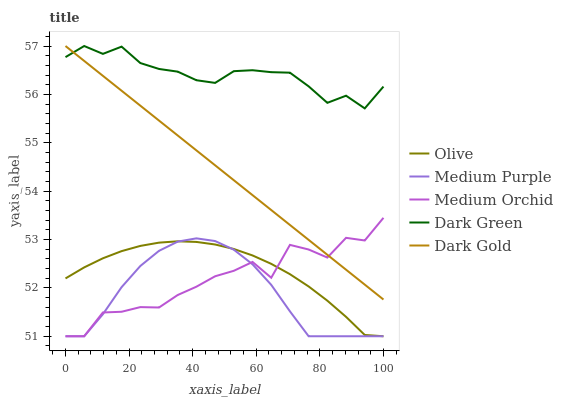Does Medium Purple have the minimum area under the curve?
Answer yes or no. Yes. Does Dark Green have the maximum area under the curve?
Answer yes or no. Yes. Does Medium Orchid have the minimum area under the curve?
Answer yes or no. No. Does Medium Orchid have the maximum area under the curve?
Answer yes or no. No. Is Dark Gold the smoothest?
Answer yes or no. Yes. Is Medium Orchid the roughest?
Answer yes or no. Yes. Is Medium Purple the smoothest?
Answer yes or no. No. Is Medium Purple the roughest?
Answer yes or no. No. Does Dark Gold have the lowest value?
Answer yes or no. No. Does Dark Green have the highest value?
Answer yes or no. Yes. Does Medium Purple have the highest value?
Answer yes or no. No. Is Olive less than Dark Green?
Answer yes or no. Yes. Is Dark Green greater than Medium Orchid?
Answer yes or no. Yes. Does Dark Gold intersect Dark Green?
Answer yes or no. Yes. Is Dark Gold less than Dark Green?
Answer yes or no. No. Is Dark Gold greater than Dark Green?
Answer yes or no. No. Does Olive intersect Dark Green?
Answer yes or no. No. 